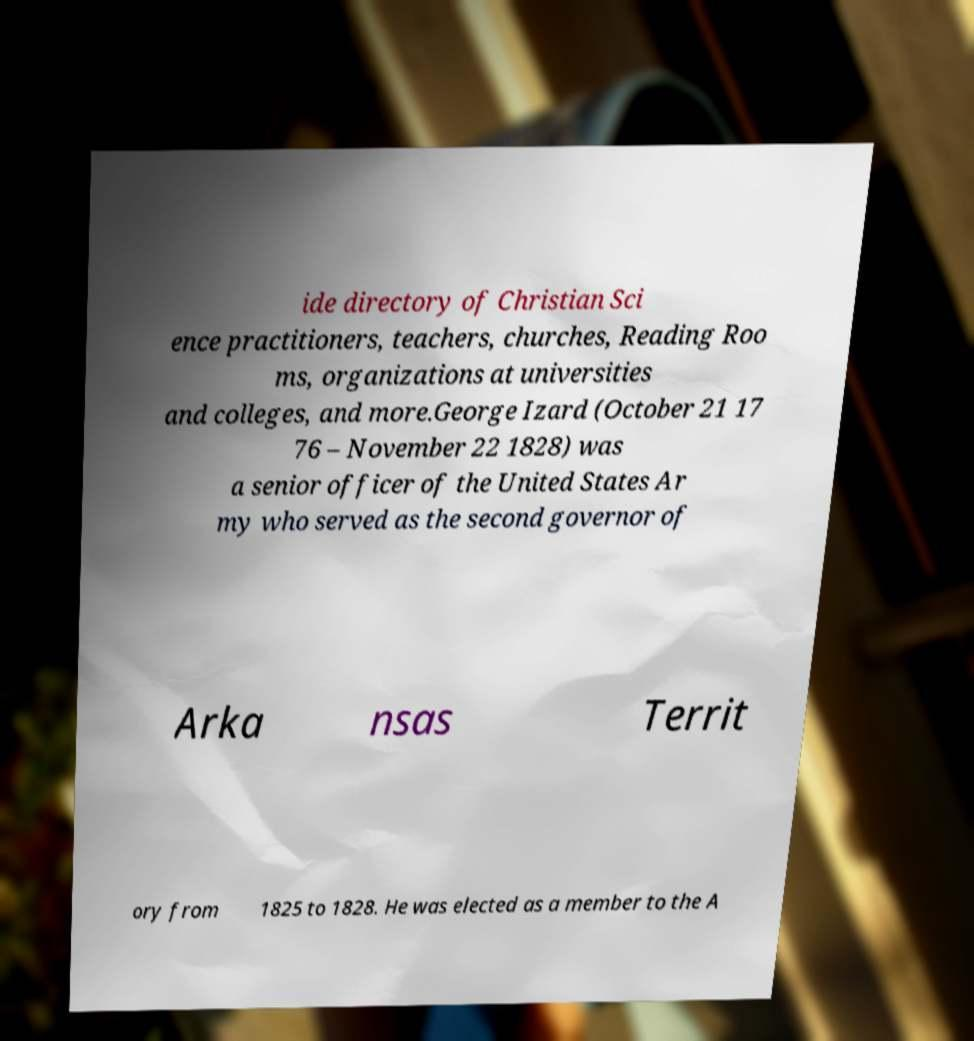I need the written content from this picture converted into text. Can you do that? ide directory of Christian Sci ence practitioners, teachers, churches, Reading Roo ms, organizations at universities and colleges, and more.George Izard (October 21 17 76 – November 22 1828) was a senior officer of the United States Ar my who served as the second governor of Arka nsas Territ ory from 1825 to 1828. He was elected as a member to the A 